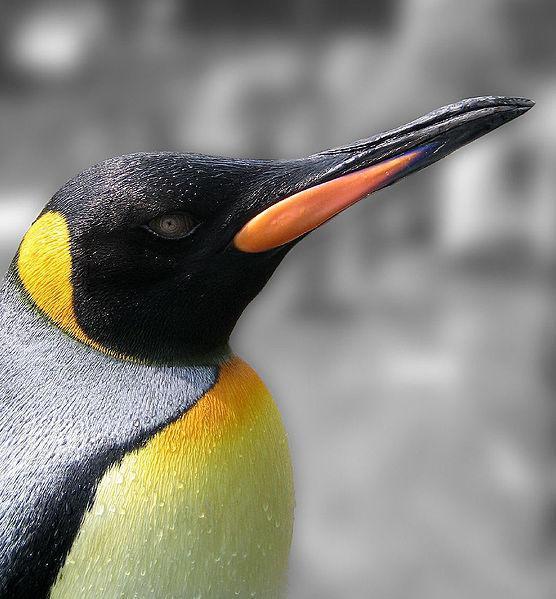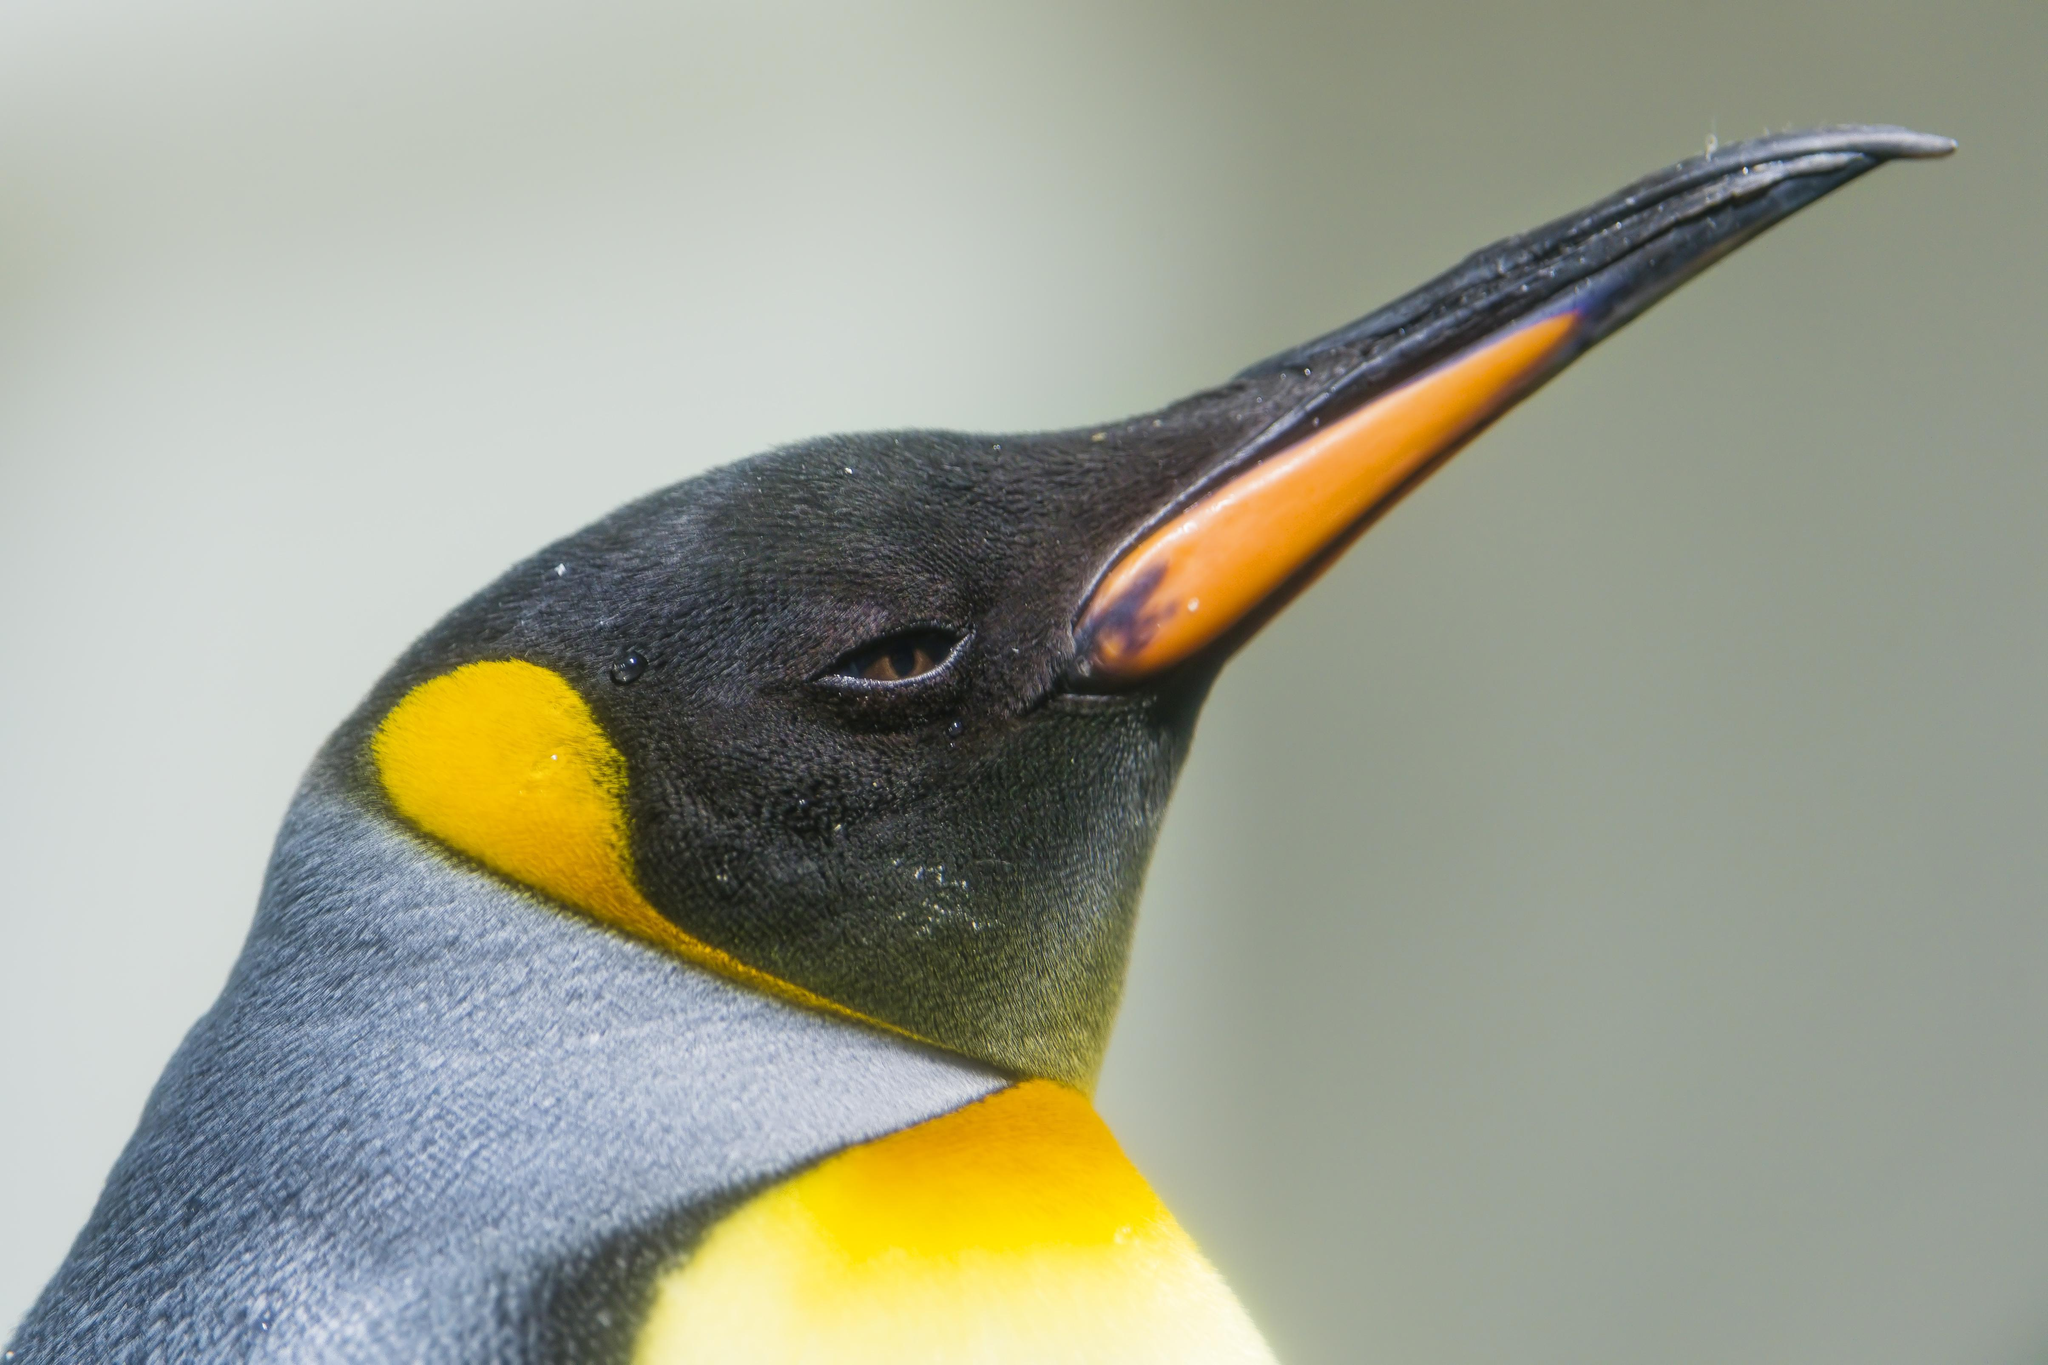The first image is the image on the left, the second image is the image on the right. Examine the images to the left and right. Is the description "There are exactly animals in the image on the right." accurate? Answer yes or no. No. 